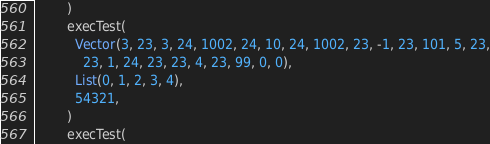<code> <loc_0><loc_0><loc_500><loc_500><_Scala_>        )
        execTest(
          Vector(3, 23, 3, 24, 1002, 24, 10, 24, 1002, 23, -1, 23, 101, 5, 23,
            23, 1, 24, 23, 23, 4, 23, 99, 0, 0),
          List(0, 1, 2, 3, 4),
          54321,
        )
        execTest(</code> 